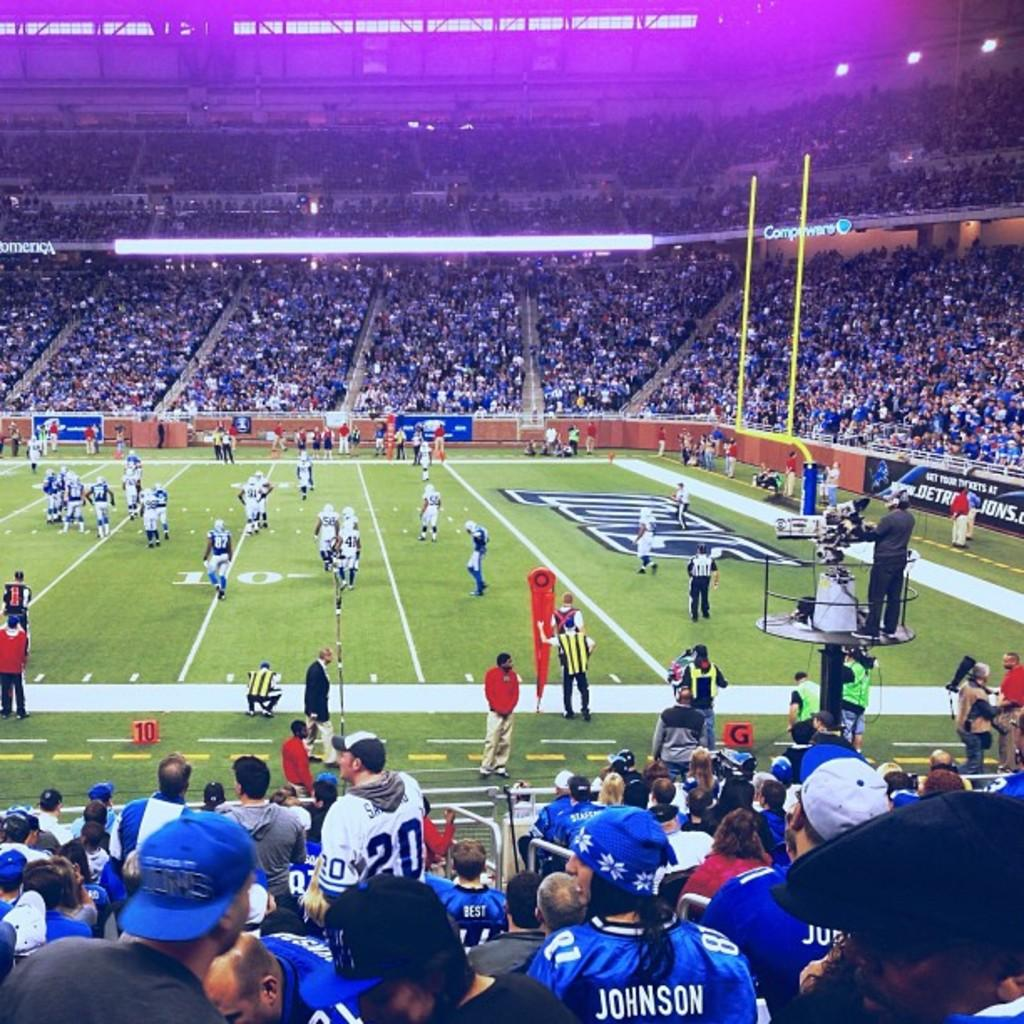Where was the image taken? The image was taken in a stadium. What sport is being played in the image? People are playing football in the center of the image. Can you describe the people in the image? There is a crowd at the bottom of the image. What can be seen in the background of the image? Boards and lights are visible in the background of the image. What channel is the football game being broadcasted on in the image? The image does not show any television or broadcasting equipment, so it is not possible to determine the channel. Is there an oven visible in the image? No, there is no oven present in the image. 